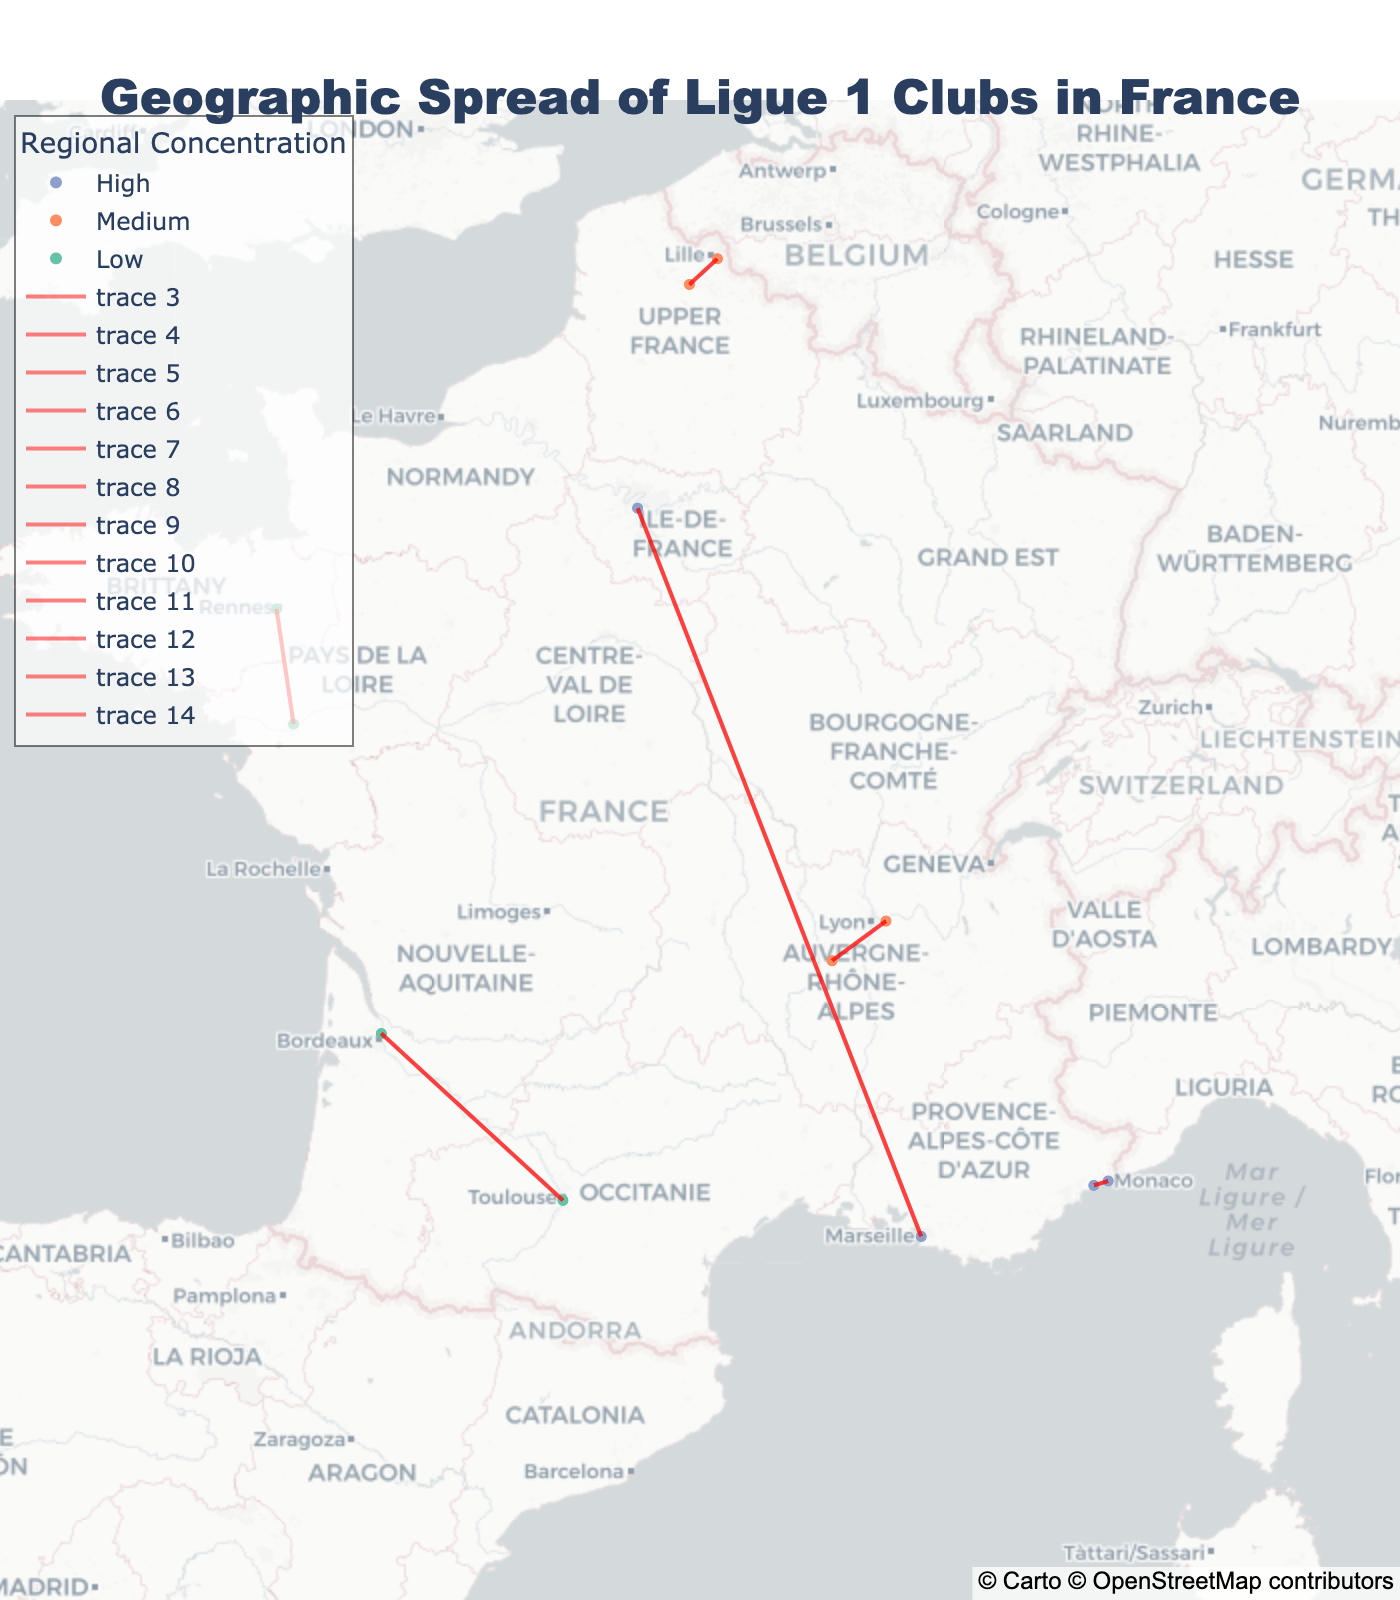How many clubs are represented in the Provence-Alpes-Côte d'Azur region? Check the data to identify the clubs in the Provence-Alpes-Côte d'Azur region: OGC Nice, AS Monaco, Olympique de Marseille. Count the clubs
Answer: 3 Which rivalry line is shown between clubs in the Auvergne-Rhône-Alpes region? The clubs in the Auvergne-Rhône-Alpes region are Olympique Lyonnais and AS Saint-Étienne, and there is a red line between them indicating a rivalry
Answer: Olympique Lyonnais and AS Saint-Étienne Which clubs have a high level of regional concentration? Identify clubs with "High" regional concentration from the map: OGC Nice, AS Monaco, Olympique de Marseille, and Paris Saint-Germain
Answer: OGC Nice, AS Monaco, Olympique de Marseille, Paris Saint-Germain Who is the rival of OGC Nice and where is it located? The rival of OGC Nice is AS Monaco, which is located in Monaco (Latitude: 43.7384, Longitude: 7.4246). This information can be cross-checked from the map
Answer: AS Monaco, located in Monaco Which region has the lowest number of clubs and what are they? Compare the number of clubs in each region by counting them. Monaco (adjacent to PACA) and Brittany have the least, each with one club (AS Monaco and Stade Rennais respectively)
Answer: Monaco and Brittany, AS Monaco and Stade Rennais How many clubs are there in the Île-de-France region? Count the number of clubs in the Île-de-France region. There is only one club: Paris Saint-Germain
Answer: 1 Which clubs are the most geographically close to OGC Nice? Identify clubs with nearby geographic coordinates by looking at latitudes and longitudes. AS Monaco is geographically closest to OGC Nice
Answer: AS Monaco What is common between clubs with a high level of regional concentration? Analyze clubs with high regional concentration: they all come from regions with multiple clubs and have notable rivalries
Answer: Multiple clubs in the region and notable rivalries Which club is located furthest north in France? From the map, identify the club with the highest latitude value. Lille OSC is the northernmost club located at Latitude 50.6119
Answer: Lille OSC Which club located the furthest west and what is its rivalry connection? Identify the club with the lowest longitude value. FC Nantes is located at Longitude -1.5253 and its rival is Stade Rennais, seen connected by a line on the map
Answer: FC Nantes, rivalry with Stade Rennais 